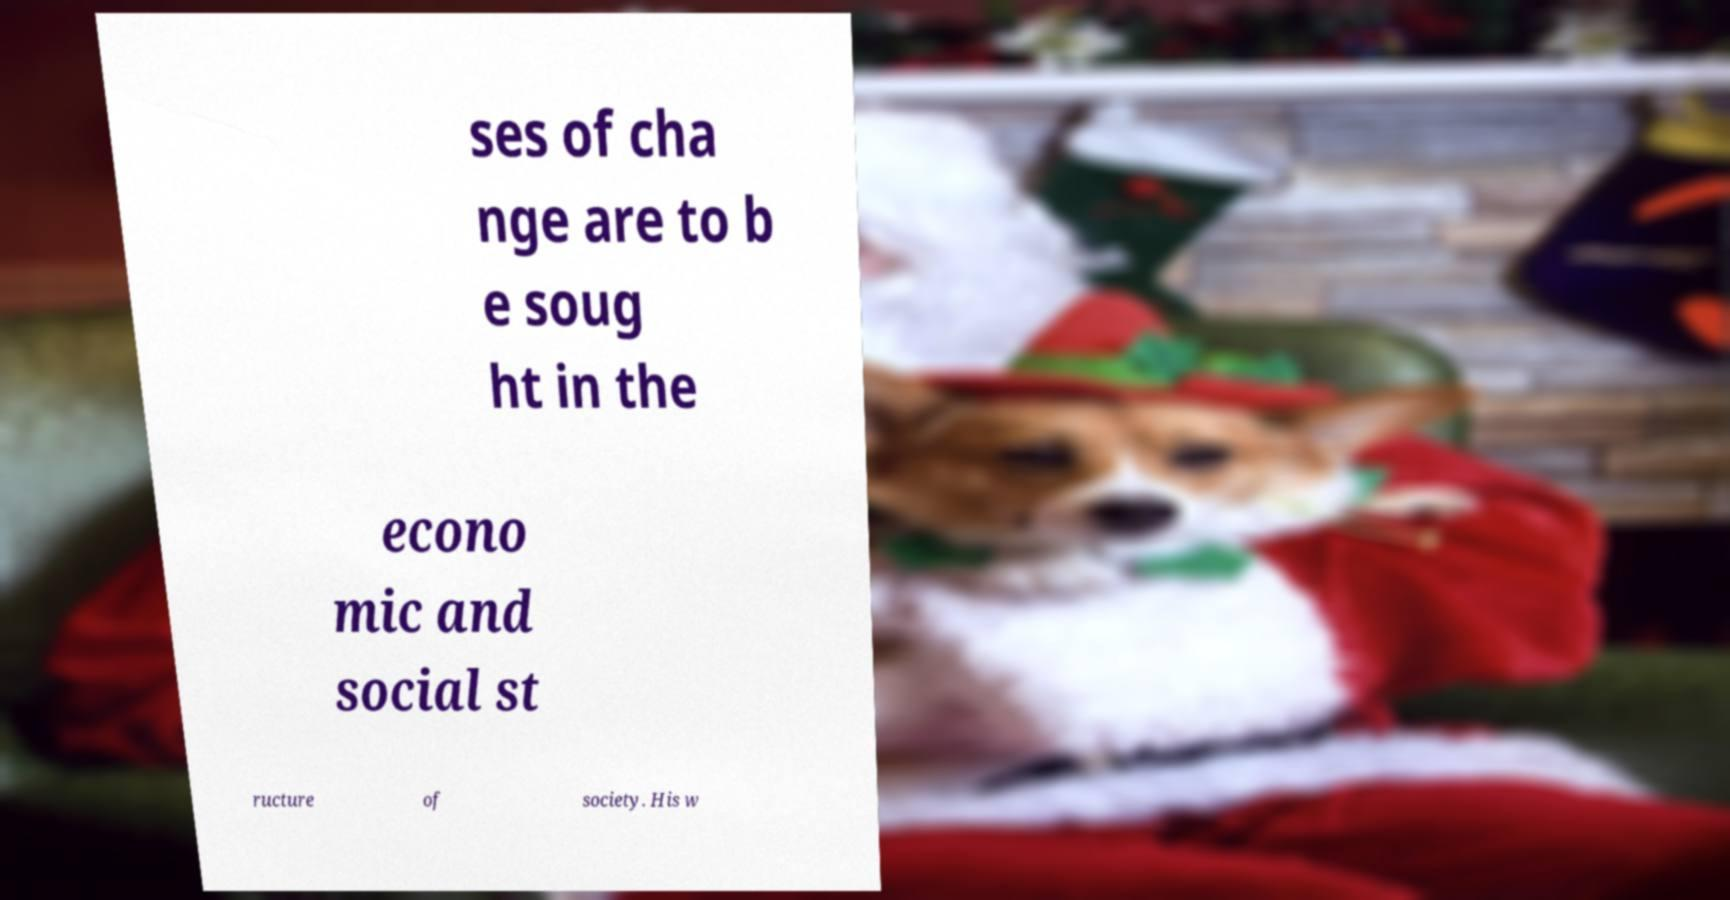What messages or text are displayed in this image? I need them in a readable, typed format. ses of cha nge are to b e soug ht in the econo mic and social st ructure of society. His w 